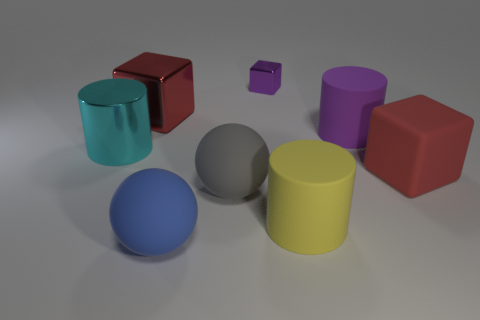Add 1 blue matte things. How many objects exist? 9 Subtract all spheres. How many objects are left? 6 Add 3 purple cubes. How many purple cubes exist? 4 Subtract 0 green cubes. How many objects are left? 8 Subtract all large cyan shiny blocks. Subtract all tiny metal cubes. How many objects are left? 7 Add 2 red objects. How many red objects are left? 4 